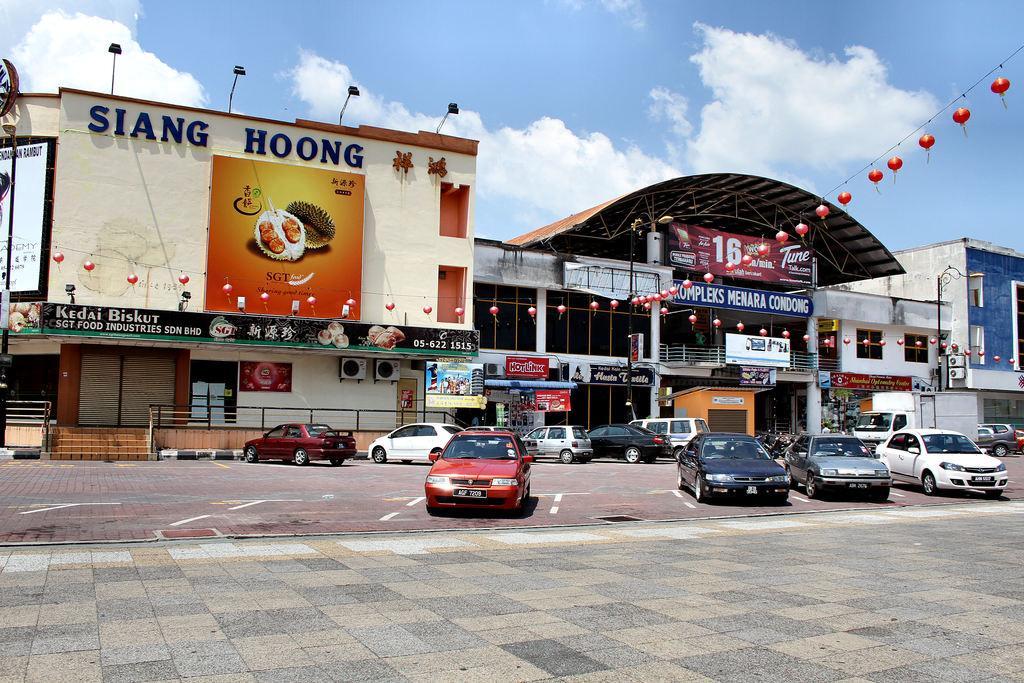Please provide a concise description of this image. In this image we can see a few cars parked in front of a shopping complex. 